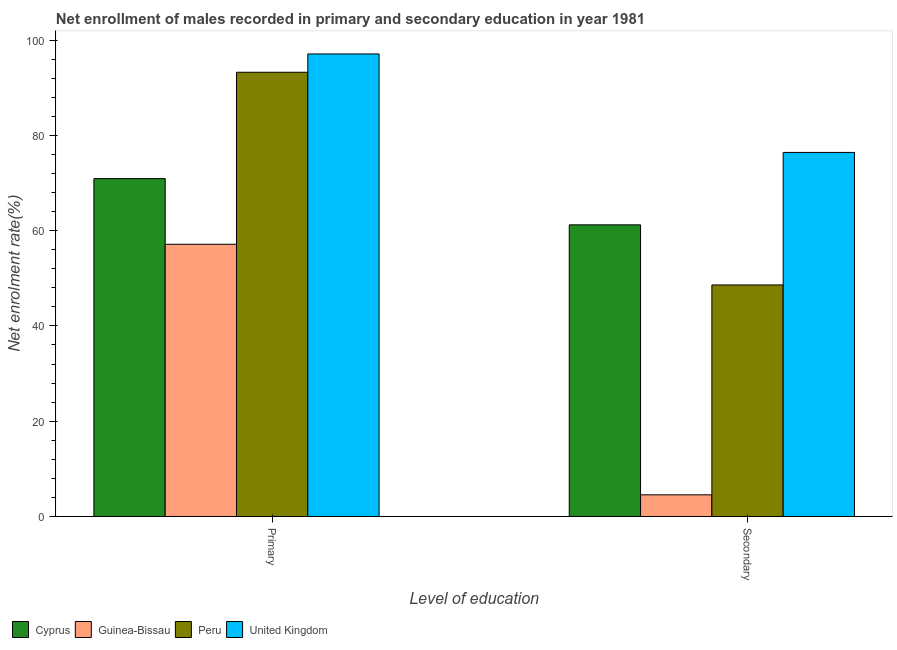How many different coloured bars are there?
Give a very brief answer. 4. Are the number of bars per tick equal to the number of legend labels?
Keep it short and to the point. Yes. Are the number of bars on each tick of the X-axis equal?
Offer a very short reply. Yes. How many bars are there on the 1st tick from the left?
Your answer should be compact. 4. What is the label of the 2nd group of bars from the left?
Give a very brief answer. Secondary. What is the enrollment rate in secondary education in Peru?
Your answer should be very brief. 48.6. Across all countries, what is the maximum enrollment rate in secondary education?
Provide a succinct answer. 76.42. Across all countries, what is the minimum enrollment rate in secondary education?
Provide a short and direct response. 4.55. In which country was the enrollment rate in secondary education maximum?
Keep it short and to the point. United Kingdom. In which country was the enrollment rate in secondary education minimum?
Your response must be concise. Guinea-Bissau. What is the total enrollment rate in secondary education in the graph?
Your answer should be very brief. 190.79. What is the difference between the enrollment rate in primary education in Peru and that in Cyprus?
Provide a succinct answer. 22.32. What is the difference between the enrollment rate in primary education in Cyprus and the enrollment rate in secondary education in United Kingdom?
Offer a terse response. -5.49. What is the average enrollment rate in secondary education per country?
Keep it short and to the point. 47.7. What is the difference between the enrollment rate in secondary education and enrollment rate in primary education in Peru?
Provide a short and direct response. -44.64. In how many countries, is the enrollment rate in primary education greater than 60 %?
Give a very brief answer. 3. What is the ratio of the enrollment rate in secondary education in Cyprus to that in United Kingdom?
Your answer should be very brief. 0.8. Is the enrollment rate in primary education in Guinea-Bissau less than that in Peru?
Offer a very short reply. Yes. What does the 3rd bar from the left in Primary represents?
Your answer should be very brief. Peru. What does the 4th bar from the right in Primary represents?
Your response must be concise. Cyprus. Are all the bars in the graph horizontal?
Keep it short and to the point. No. How many countries are there in the graph?
Offer a terse response. 4. What is the difference between two consecutive major ticks on the Y-axis?
Provide a succinct answer. 20. Are the values on the major ticks of Y-axis written in scientific E-notation?
Provide a succinct answer. No. Where does the legend appear in the graph?
Give a very brief answer. Bottom left. How many legend labels are there?
Keep it short and to the point. 4. What is the title of the graph?
Make the answer very short. Net enrollment of males recorded in primary and secondary education in year 1981. Does "Caribbean small states" appear as one of the legend labels in the graph?
Give a very brief answer. No. What is the label or title of the X-axis?
Offer a very short reply. Level of education. What is the label or title of the Y-axis?
Your answer should be very brief. Net enrolment rate(%). What is the Net enrolment rate(%) in Cyprus in Primary?
Offer a terse response. 70.92. What is the Net enrolment rate(%) in Guinea-Bissau in Primary?
Ensure brevity in your answer.  57.14. What is the Net enrolment rate(%) of Peru in Primary?
Provide a short and direct response. 93.24. What is the Net enrolment rate(%) of United Kingdom in Primary?
Your response must be concise. 97.08. What is the Net enrolment rate(%) in Cyprus in Secondary?
Give a very brief answer. 61.22. What is the Net enrolment rate(%) in Guinea-Bissau in Secondary?
Offer a terse response. 4.55. What is the Net enrolment rate(%) in Peru in Secondary?
Your answer should be very brief. 48.6. What is the Net enrolment rate(%) in United Kingdom in Secondary?
Your answer should be compact. 76.42. Across all Level of education, what is the maximum Net enrolment rate(%) in Cyprus?
Your answer should be compact. 70.92. Across all Level of education, what is the maximum Net enrolment rate(%) in Guinea-Bissau?
Your response must be concise. 57.14. Across all Level of education, what is the maximum Net enrolment rate(%) in Peru?
Give a very brief answer. 93.24. Across all Level of education, what is the maximum Net enrolment rate(%) in United Kingdom?
Offer a very short reply. 97.08. Across all Level of education, what is the minimum Net enrolment rate(%) of Cyprus?
Offer a terse response. 61.22. Across all Level of education, what is the minimum Net enrolment rate(%) in Guinea-Bissau?
Your answer should be compact. 4.55. Across all Level of education, what is the minimum Net enrolment rate(%) in Peru?
Offer a terse response. 48.6. Across all Level of education, what is the minimum Net enrolment rate(%) in United Kingdom?
Offer a terse response. 76.42. What is the total Net enrolment rate(%) of Cyprus in the graph?
Provide a succinct answer. 132.14. What is the total Net enrolment rate(%) in Guinea-Bissau in the graph?
Keep it short and to the point. 61.69. What is the total Net enrolment rate(%) of Peru in the graph?
Your answer should be compact. 141.84. What is the total Net enrolment rate(%) of United Kingdom in the graph?
Provide a succinct answer. 173.5. What is the difference between the Net enrolment rate(%) in Cyprus in Primary and that in Secondary?
Provide a short and direct response. 9.71. What is the difference between the Net enrolment rate(%) in Guinea-Bissau in Primary and that in Secondary?
Your response must be concise. 52.59. What is the difference between the Net enrolment rate(%) of Peru in Primary and that in Secondary?
Provide a short and direct response. 44.64. What is the difference between the Net enrolment rate(%) of United Kingdom in Primary and that in Secondary?
Your response must be concise. 20.67. What is the difference between the Net enrolment rate(%) in Cyprus in Primary and the Net enrolment rate(%) in Guinea-Bissau in Secondary?
Your answer should be very brief. 66.37. What is the difference between the Net enrolment rate(%) in Cyprus in Primary and the Net enrolment rate(%) in Peru in Secondary?
Ensure brevity in your answer.  22.32. What is the difference between the Net enrolment rate(%) in Cyprus in Primary and the Net enrolment rate(%) in United Kingdom in Secondary?
Provide a succinct answer. -5.49. What is the difference between the Net enrolment rate(%) of Guinea-Bissau in Primary and the Net enrolment rate(%) of Peru in Secondary?
Give a very brief answer. 8.54. What is the difference between the Net enrolment rate(%) of Guinea-Bissau in Primary and the Net enrolment rate(%) of United Kingdom in Secondary?
Your response must be concise. -19.28. What is the difference between the Net enrolment rate(%) of Peru in Primary and the Net enrolment rate(%) of United Kingdom in Secondary?
Give a very brief answer. 16.83. What is the average Net enrolment rate(%) of Cyprus per Level of education?
Your response must be concise. 66.07. What is the average Net enrolment rate(%) in Guinea-Bissau per Level of education?
Ensure brevity in your answer.  30.85. What is the average Net enrolment rate(%) in Peru per Level of education?
Ensure brevity in your answer.  70.92. What is the average Net enrolment rate(%) in United Kingdom per Level of education?
Your response must be concise. 86.75. What is the difference between the Net enrolment rate(%) in Cyprus and Net enrolment rate(%) in Guinea-Bissau in Primary?
Ensure brevity in your answer.  13.78. What is the difference between the Net enrolment rate(%) of Cyprus and Net enrolment rate(%) of Peru in Primary?
Keep it short and to the point. -22.32. What is the difference between the Net enrolment rate(%) of Cyprus and Net enrolment rate(%) of United Kingdom in Primary?
Give a very brief answer. -26.16. What is the difference between the Net enrolment rate(%) in Guinea-Bissau and Net enrolment rate(%) in Peru in Primary?
Ensure brevity in your answer.  -36.1. What is the difference between the Net enrolment rate(%) of Guinea-Bissau and Net enrolment rate(%) of United Kingdom in Primary?
Keep it short and to the point. -39.94. What is the difference between the Net enrolment rate(%) in Peru and Net enrolment rate(%) in United Kingdom in Primary?
Provide a short and direct response. -3.84. What is the difference between the Net enrolment rate(%) of Cyprus and Net enrolment rate(%) of Guinea-Bissau in Secondary?
Your answer should be very brief. 56.66. What is the difference between the Net enrolment rate(%) in Cyprus and Net enrolment rate(%) in Peru in Secondary?
Keep it short and to the point. 12.62. What is the difference between the Net enrolment rate(%) in Cyprus and Net enrolment rate(%) in United Kingdom in Secondary?
Your answer should be very brief. -15.2. What is the difference between the Net enrolment rate(%) in Guinea-Bissau and Net enrolment rate(%) in Peru in Secondary?
Keep it short and to the point. -44.05. What is the difference between the Net enrolment rate(%) of Guinea-Bissau and Net enrolment rate(%) of United Kingdom in Secondary?
Make the answer very short. -71.86. What is the difference between the Net enrolment rate(%) of Peru and Net enrolment rate(%) of United Kingdom in Secondary?
Provide a succinct answer. -27.81. What is the ratio of the Net enrolment rate(%) in Cyprus in Primary to that in Secondary?
Keep it short and to the point. 1.16. What is the ratio of the Net enrolment rate(%) of Guinea-Bissau in Primary to that in Secondary?
Your response must be concise. 12.55. What is the ratio of the Net enrolment rate(%) in Peru in Primary to that in Secondary?
Offer a terse response. 1.92. What is the ratio of the Net enrolment rate(%) of United Kingdom in Primary to that in Secondary?
Make the answer very short. 1.27. What is the difference between the highest and the second highest Net enrolment rate(%) of Cyprus?
Give a very brief answer. 9.71. What is the difference between the highest and the second highest Net enrolment rate(%) in Guinea-Bissau?
Make the answer very short. 52.59. What is the difference between the highest and the second highest Net enrolment rate(%) of Peru?
Ensure brevity in your answer.  44.64. What is the difference between the highest and the second highest Net enrolment rate(%) of United Kingdom?
Give a very brief answer. 20.67. What is the difference between the highest and the lowest Net enrolment rate(%) of Cyprus?
Your answer should be compact. 9.71. What is the difference between the highest and the lowest Net enrolment rate(%) in Guinea-Bissau?
Provide a succinct answer. 52.59. What is the difference between the highest and the lowest Net enrolment rate(%) of Peru?
Provide a succinct answer. 44.64. What is the difference between the highest and the lowest Net enrolment rate(%) in United Kingdom?
Keep it short and to the point. 20.67. 